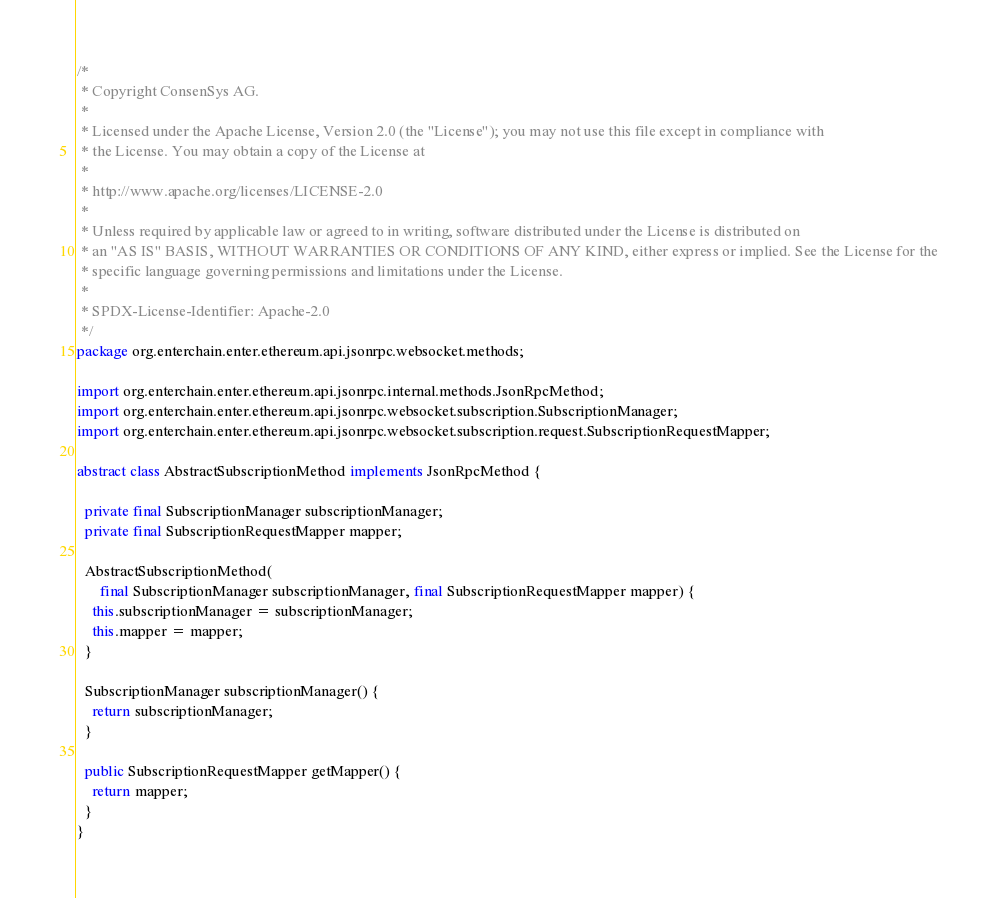<code> <loc_0><loc_0><loc_500><loc_500><_Java_>/*
 * Copyright ConsenSys AG.
 *
 * Licensed under the Apache License, Version 2.0 (the "License"); you may not use this file except in compliance with
 * the License. You may obtain a copy of the License at
 *
 * http://www.apache.org/licenses/LICENSE-2.0
 *
 * Unless required by applicable law or agreed to in writing, software distributed under the License is distributed on
 * an "AS IS" BASIS, WITHOUT WARRANTIES OR CONDITIONS OF ANY KIND, either express or implied. See the License for the
 * specific language governing permissions and limitations under the License.
 *
 * SPDX-License-Identifier: Apache-2.0
 */
package org.enterchain.enter.ethereum.api.jsonrpc.websocket.methods;

import org.enterchain.enter.ethereum.api.jsonrpc.internal.methods.JsonRpcMethod;
import org.enterchain.enter.ethereum.api.jsonrpc.websocket.subscription.SubscriptionManager;
import org.enterchain.enter.ethereum.api.jsonrpc.websocket.subscription.request.SubscriptionRequestMapper;

abstract class AbstractSubscriptionMethod implements JsonRpcMethod {

  private final SubscriptionManager subscriptionManager;
  private final SubscriptionRequestMapper mapper;

  AbstractSubscriptionMethod(
      final SubscriptionManager subscriptionManager, final SubscriptionRequestMapper mapper) {
    this.subscriptionManager = subscriptionManager;
    this.mapper = mapper;
  }

  SubscriptionManager subscriptionManager() {
    return subscriptionManager;
  }

  public SubscriptionRequestMapper getMapper() {
    return mapper;
  }
}
</code> 